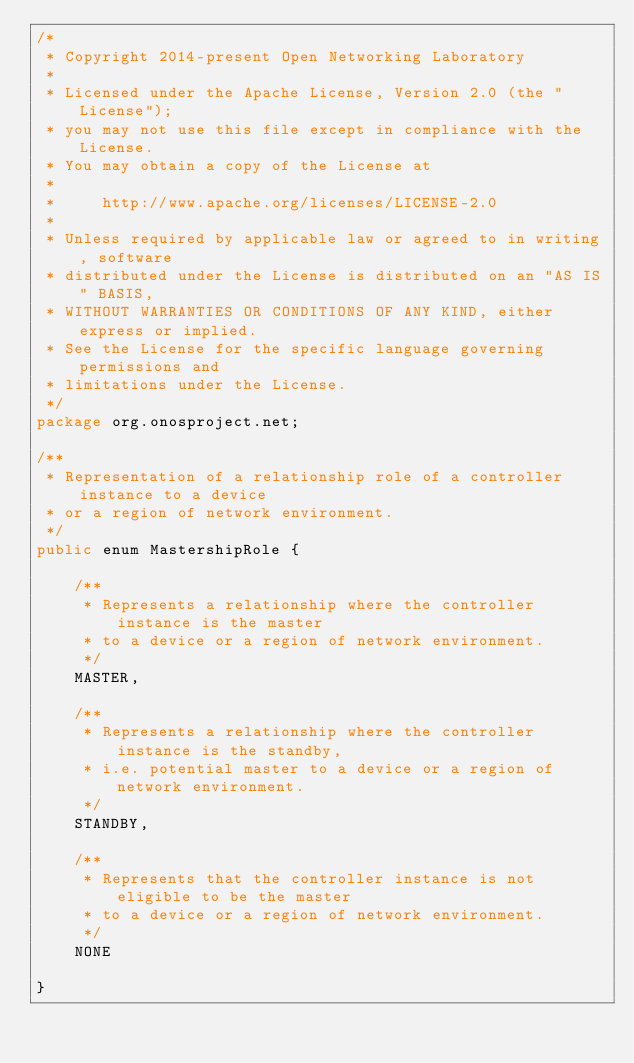Convert code to text. <code><loc_0><loc_0><loc_500><loc_500><_Java_>/*
 * Copyright 2014-present Open Networking Laboratory
 *
 * Licensed under the Apache License, Version 2.0 (the "License");
 * you may not use this file except in compliance with the License.
 * You may obtain a copy of the License at
 *
 *     http://www.apache.org/licenses/LICENSE-2.0
 *
 * Unless required by applicable law or agreed to in writing, software
 * distributed under the License is distributed on an "AS IS" BASIS,
 * WITHOUT WARRANTIES OR CONDITIONS OF ANY KIND, either express or implied.
 * See the License for the specific language governing permissions and
 * limitations under the License.
 */
package org.onosproject.net;

/**
 * Representation of a relationship role of a controller instance to a device
 * or a region of network environment.
 */
public enum MastershipRole {

    /**
     * Represents a relationship where the controller instance is the master
     * to a device or a region of network environment.
     */
    MASTER,

    /**
     * Represents a relationship where the controller instance is the standby,
     * i.e. potential master to a device or a region of network environment.
     */
    STANDBY,

    /**
     * Represents that the controller instance is not eligible to be the master
     * to a device or a region of network environment.
     */
    NONE

}
</code> 